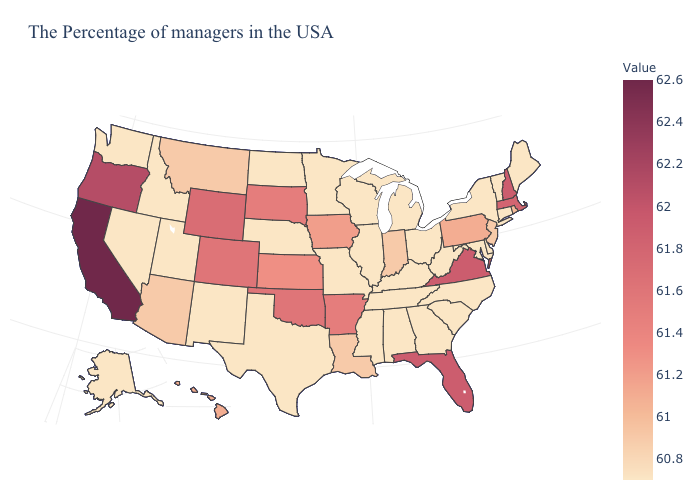Which states have the lowest value in the USA?
Give a very brief answer. Maine, Vermont, Connecticut, New York, Delaware, Maryland, North Carolina, South Carolina, West Virginia, Ohio, Georgia, Michigan, Kentucky, Alabama, Tennessee, Wisconsin, Illinois, Mississippi, Missouri, Minnesota, Nebraska, Texas, North Dakota, New Mexico, Utah, Idaho, Nevada, Washington, Alaska. Which states have the lowest value in the USA?
Concise answer only. Maine, Vermont, Connecticut, New York, Delaware, Maryland, North Carolina, South Carolina, West Virginia, Ohio, Georgia, Michigan, Kentucky, Alabama, Tennessee, Wisconsin, Illinois, Mississippi, Missouri, Minnesota, Nebraska, Texas, North Dakota, New Mexico, Utah, Idaho, Nevada, Washington, Alaska. Among the states that border Connecticut , which have the highest value?
Short answer required. Massachusetts. Does Rhode Island have a higher value than Minnesota?
Answer briefly. Yes. 